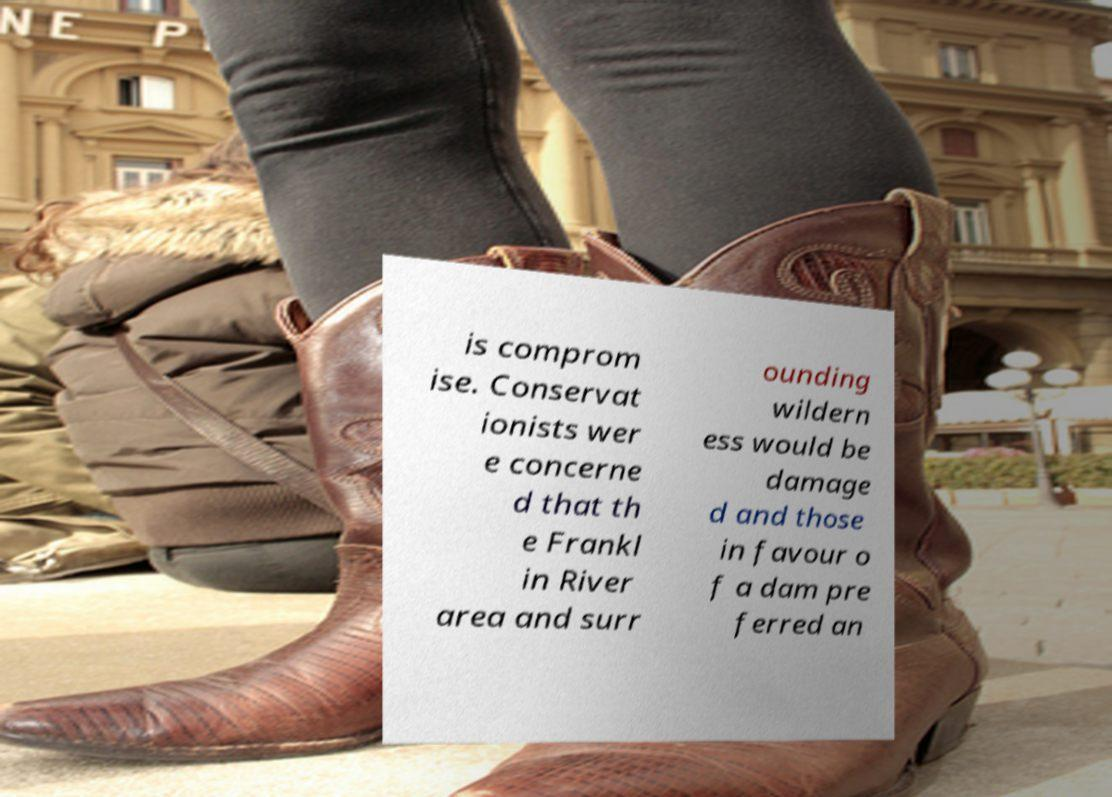There's text embedded in this image that I need extracted. Can you transcribe it verbatim? is comprom ise. Conservat ionists wer e concerne d that th e Frankl in River area and surr ounding wildern ess would be damage d and those in favour o f a dam pre ferred an 